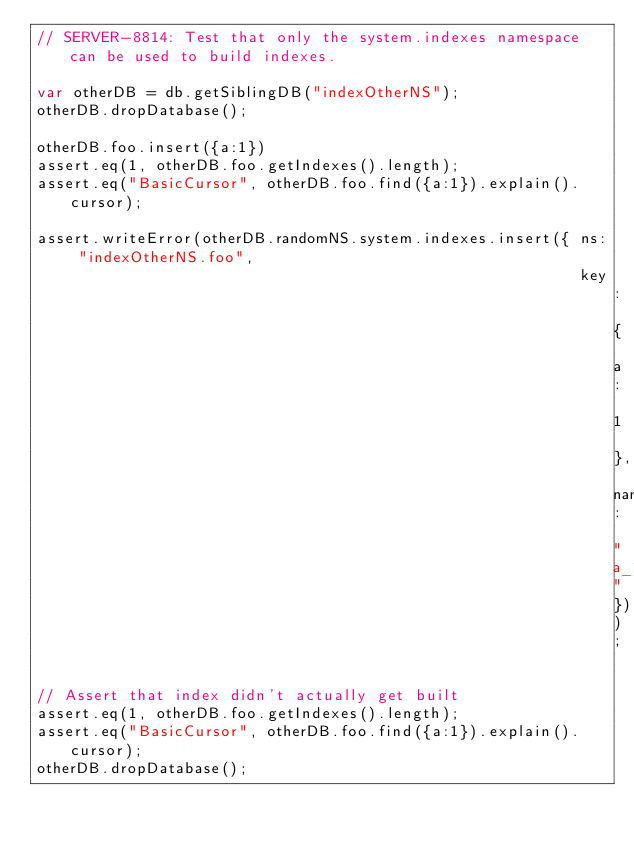<code> <loc_0><loc_0><loc_500><loc_500><_JavaScript_>// SERVER-8814: Test that only the system.indexes namespace can be used to build indexes.

var otherDB = db.getSiblingDB("indexOtherNS");
otherDB.dropDatabase();

otherDB.foo.insert({a:1})
assert.eq(1, otherDB.foo.getIndexes().length);
assert.eq("BasicCursor", otherDB.foo.find({a:1}).explain().cursor);

assert.writeError(otherDB.randomNS.system.indexes.insert({ ns: "indexOtherNS.foo",
                                                           key: { a: 1 }, name: "a_1"}));

// Assert that index didn't actually get built
assert.eq(1, otherDB.foo.getIndexes().length);
assert.eq("BasicCursor", otherDB.foo.find({a:1}).explain().cursor);
otherDB.dropDatabase();
</code> 